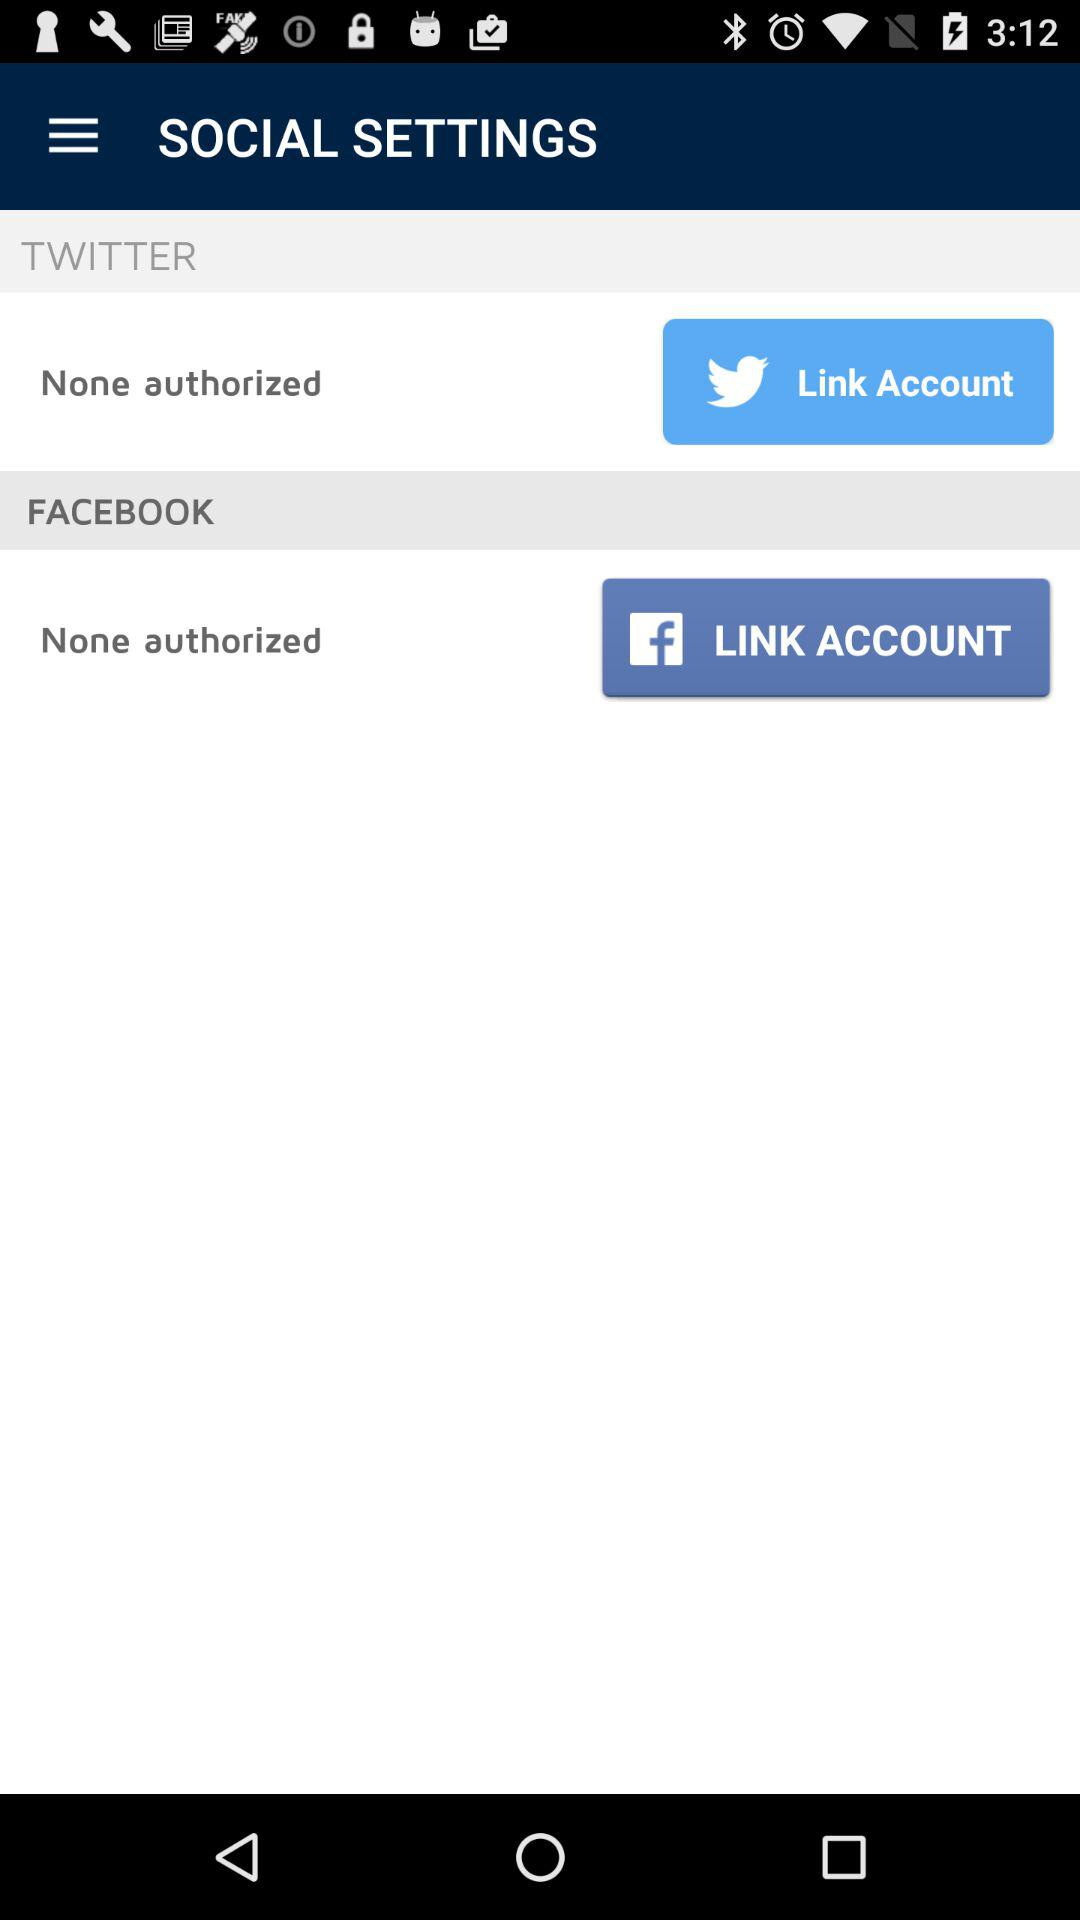Which applications aren't permitted? The applications are "TWITTER" and "FACEBOOK". 